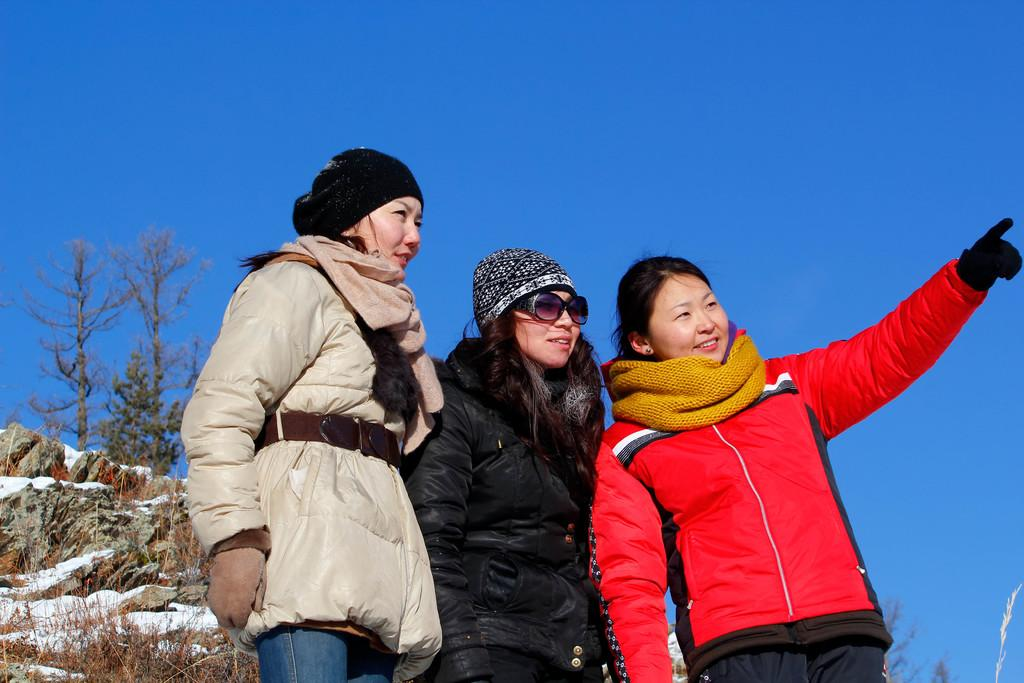How many people are present in the image? There are three people standing in the image. What type of vegetation can be seen in the image? There are trees and dried plants in the image. What other natural elements are present in the image? There are rocks in the image. What is the weather like in the image? The presence of snow suggests that it is cold in the image. What is visible in the background of the image? The sky is visible in the background of the image. What type of silk fabric is draped over the rocks in the image? There is no silk fabric present in the image; it features rocks, trees, dried plants, snow, and three people. 